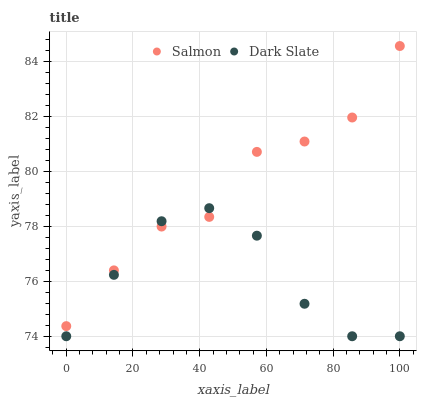Does Dark Slate have the minimum area under the curve?
Answer yes or no. Yes. Does Salmon have the maximum area under the curve?
Answer yes or no. Yes. Does Salmon have the minimum area under the curve?
Answer yes or no. No. Is Dark Slate the smoothest?
Answer yes or no. Yes. Is Salmon the roughest?
Answer yes or no. Yes. Is Salmon the smoothest?
Answer yes or no. No. Does Dark Slate have the lowest value?
Answer yes or no. Yes. Does Salmon have the lowest value?
Answer yes or no. No. Does Salmon have the highest value?
Answer yes or no. Yes. Does Salmon intersect Dark Slate?
Answer yes or no. Yes. Is Salmon less than Dark Slate?
Answer yes or no. No. Is Salmon greater than Dark Slate?
Answer yes or no. No. 